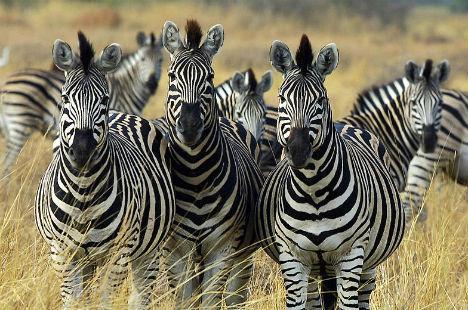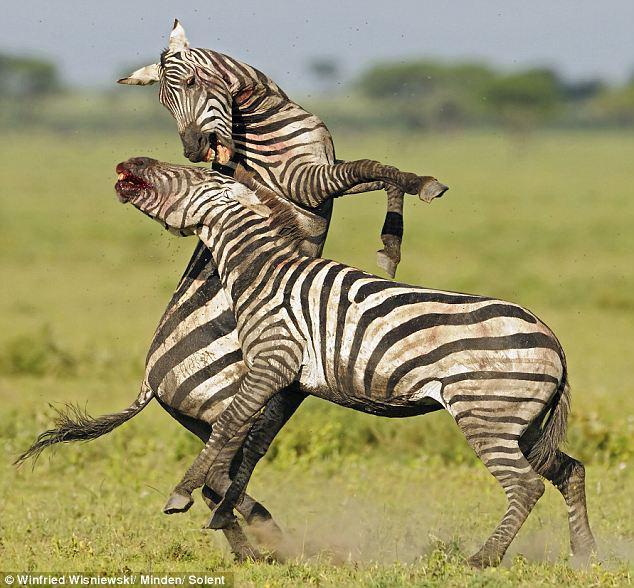The first image is the image on the left, the second image is the image on the right. Considering the images on both sides, is "One of the images shows a zebra in close contact with a mammal of another species." valid? Answer yes or no. No. The first image is the image on the left, the second image is the image on the right. For the images shown, is this caption "The photo on the right shows an animal that is not a zebra, and the one on the left shows at least two zebras in a dusty environment." true? Answer yes or no. No. 